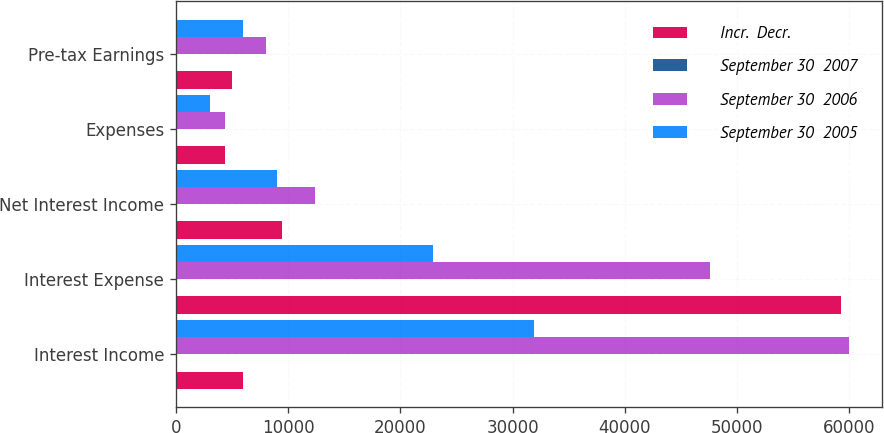<chart> <loc_0><loc_0><loc_500><loc_500><stacked_bar_chart><ecel><fcel>Interest Income<fcel>Interest Expense<fcel>Net Interest Income<fcel>Expenses<fcel>Pre-tax Earnings<nl><fcel>Incr.  Decr.<fcel>5962<fcel>59276<fcel>9409<fcel>4406<fcel>5003<nl><fcel>September 30  2007<fcel>15<fcel>25<fcel>24<fcel>1<fcel>37<nl><fcel>September 30  2006<fcel>59947<fcel>47593<fcel>12354<fcel>4353<fcel>8001<nl><fcel>September 30  2005<fcel>31876<fcel>22873<fcel>9003<fcel>3041<fcel>5962<nl></chart> 